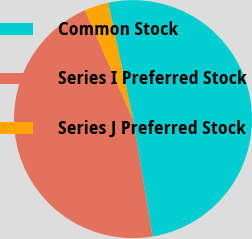Convert chart to OTSL. <chart><loc_0><loc_0><loc_500><loc_500><pie_chart><fcel>Common Stock<fcel>Series I Preferred Stock<fcel>Series J Preferred Stock<nl><fcel>50.71%<fcel>46.03%<fcel>3.26%<nl></chart> 